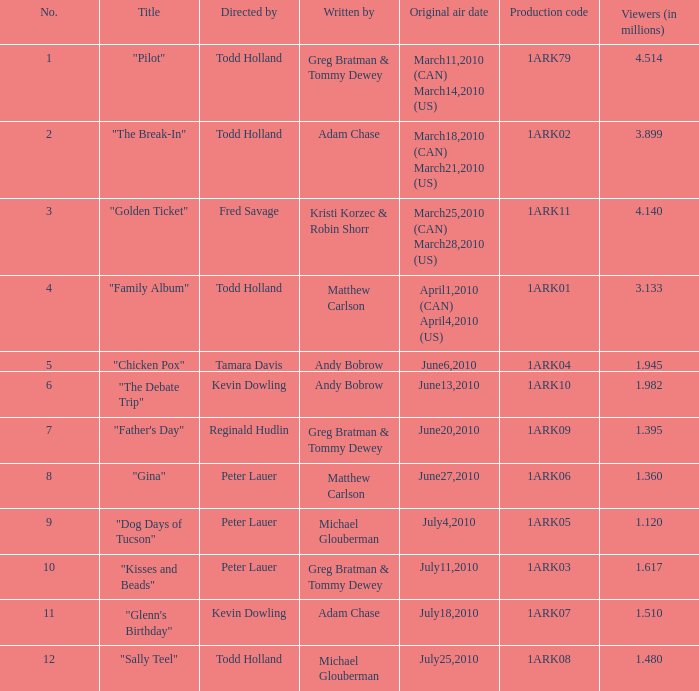When was the initial broadcast date for the production with code 1ark79? March11,2010 (CAN) March14,2010 (US). 